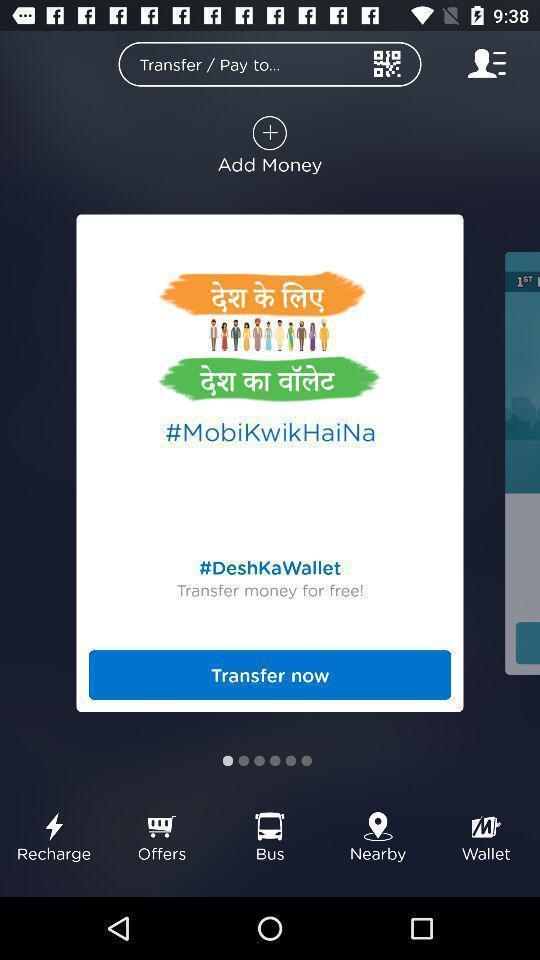What details can you identify in this image? Popup showing information about transfer. 